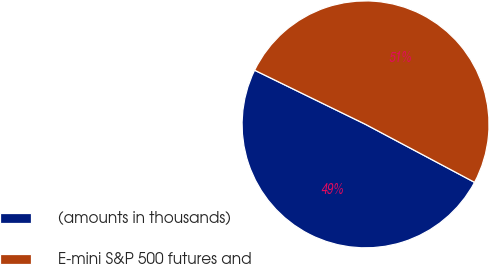Convert chart. <chart><loc_0><loc_0><loc_500><loc_500><pie_chart><fcel>(amounts in thousands)<fcel>E-mini S&P 500 futures and<nl><fcel>49.45%<fcel>50.55%<nl></chart> 